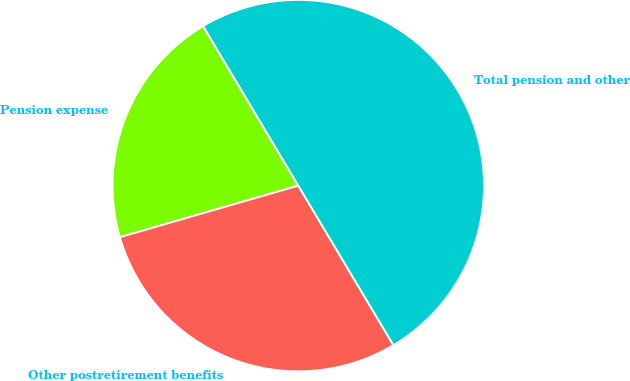<chart> <loc_0><loc_0><loc_500><loc_500><pie_chart><fcel>Pension expense<fcel>Other postretirement benefits<fcel>Total pension and other<nl><fcel>20.92%<fcel>29.08%<fcel>50.0%<nl></chart> 